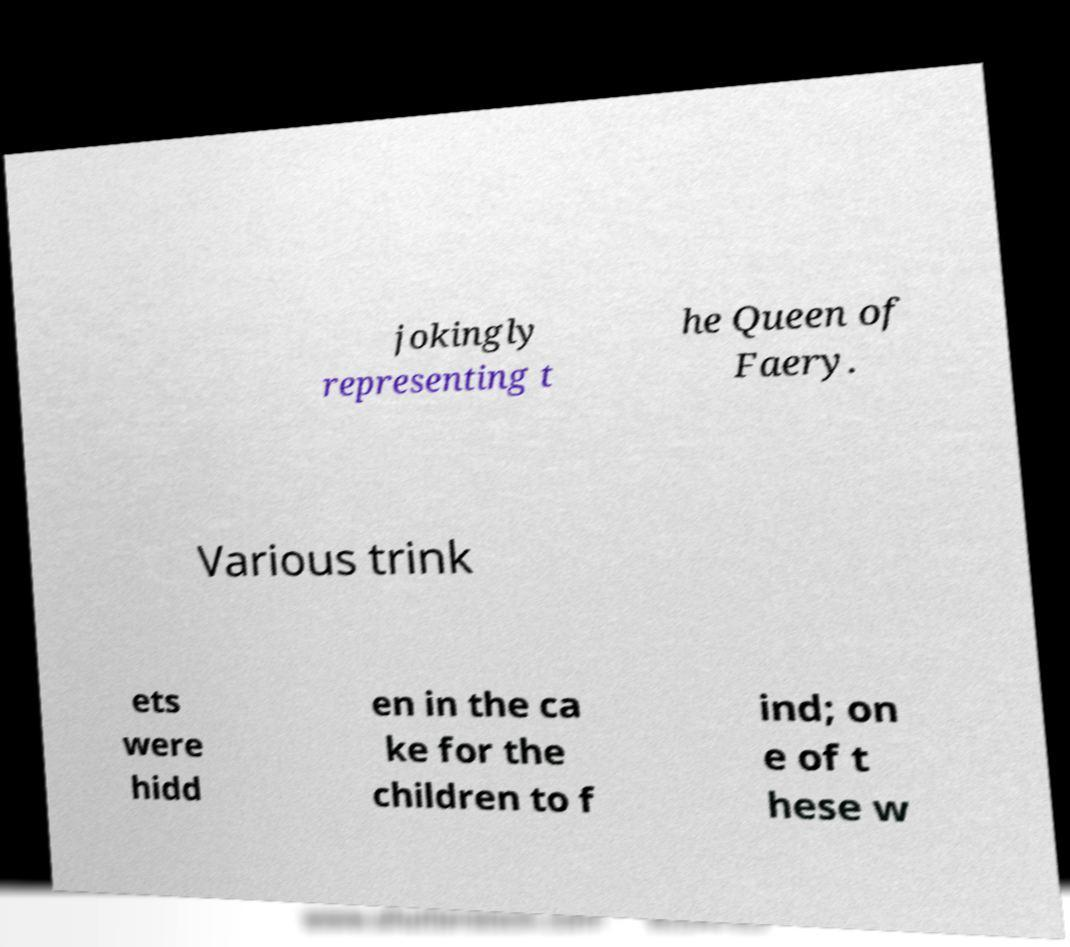Can you accurately transcribe the text from the provided image for me? jokingly representing t he Queen of Faery. Various trink ets were hidd en in the ca ke for the children to f ind; on e of t hese w 